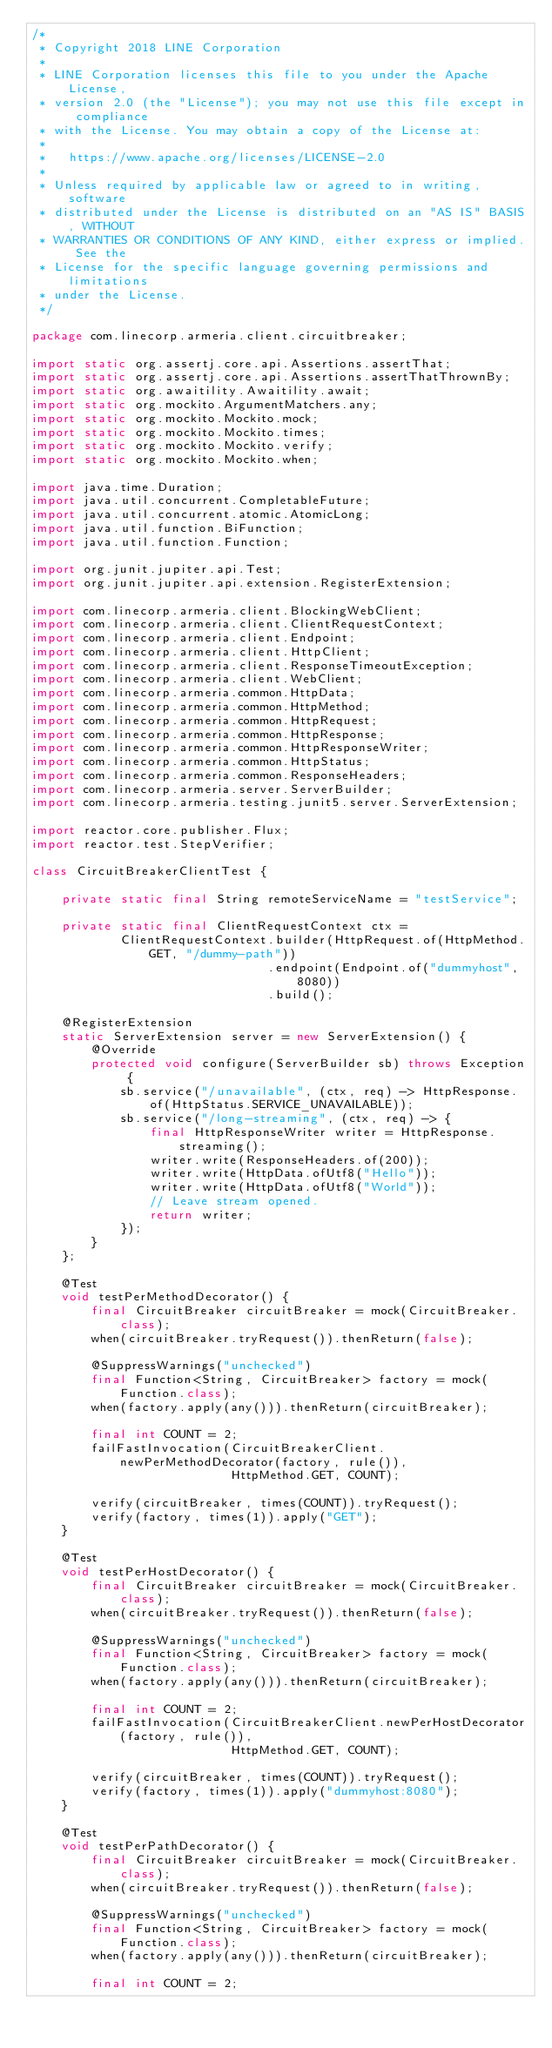<code> <loc_0><loc_0><loc_500><loc_500><_Java_>/*
 * Copyright 2018 LINE Corporation
 *
 * LINE Corporation licenses this file to you under the Apache License,
 * version 2.0 (the "License"); you may not use this file except in compliance
 * with the License. You may obtain a copy of the License at:
 *
 *   https://www.apache.org/licenses/LICENSE-2.0
 *
 * Unless required by applicable law or agreed to in writing, software
 * distributed under the License is distributed on an "AS IS" BASIS, WITHOUT
 * WARRANTIES OR CONDITIONS OF ANY KIND, either express or implied. See the
 * License for the specific language governing permissions and limitations
 * under the License.
 */

package com.linecorp.armeria.client.circuitbreaker;

import static org.assertj.core.api.Assertions.assertThat;
import static org.assertj.core.api.Assertions.assertThatThrownBy;
import static org.awaitility.Awaitility.await;
import static org.mockito.ArgumentMatchers.any;
import static org.mockito.Mockito.mock;
import static org.mockito.Mockito.times;
import static org.mockito.Mockito.verify;
import static org.mockito.Mockito.when;

import java.time.Duration;
import java.util.concurrent.CompletableFuture;
import java.util.concurrent.atomic.AtomicLong;
import java.util.function.BiFunction;
import java.util.function.Function;

import org.junit.jupiter.api.Test;
import org.junit.jupiter.api.extension.RegisterExtension;

import com.linecorp.armeria.client.BlockingWebClient;
import com.linecorp.armeria.client.ClientRequestContext;
import com.linecorp.armeria.client.Endpoint;
import com.linecorp.armeria.client.HttpClient;
import com.linecorp.armeria.client.ResponseTimeoutException;
import com.linecorp.armeria.client.WebClient;
import com.linecorp.armeria.common.HttpData;
import com.linecorp.armeria.common.HttpMethod;
import com.linecorp.armeria.common.HttpRequest;
import com.linecorp.armeria.common.HttpResponse;
import com.linecorp.armeria.common.HttpResponseWriter;
import com.linecorp.armeria.common.HttpStatus;
import com.linecorp.armeria.common.ResponseHeaders;
import com.linecorp.armeria.server.ServerBuilder;
import com.linecorp.armeria.testing.junit5.server.ServerExtension;

import reactor.core.publisher.Flux;
import reactor.test.StepVerifier;

class CircuitBreakerClientTest {

    private static final String remoteServiceName = "testService";

    private static final ClientRequestContext ctx =
            ClientRequestContext.builder(HttpRequest.of(HttpMethod.GET, "/dummy-path"))
                                .endpoint(Endpoint.of("dummyhost", 8080))
                                .build();

    @RegisterExtension
    static ServerExtension server = new ServerExtension() {
        @Override
        protected void configure(ServerBuilder sb) throws Exception {
            sb.service("/unavailable", (ctx, req) -> HttpResponse.of(HttpStatus.SERVICE_UNAVAILABLE));
            sb.service("/long-streaming", (ctx, req) -> {
                final HttpResponseWriter writer = HttpResponse.streaming();
                writer.write(ResponseHeaders.of(200));
                writer.write(HttpData.ofUtf8("Hello"));
                writer.write(HttpData.ofUtf8("World"));
                // Leave stream opened.
                return writer;
            });
        }
    };

    @Test
    void testPerMethodDecorator() {
        final CircuitBreaker circuitBreaker = mock(CircuitBreaker.class);
        when(circuitBreaker.tryRequest()).thenReturn(false);

        @SuppressWarnings("unchecked")
        final Function<String, CircuitBreaker> factory = mock(Function.class);
        when(factory.apply(any())).thenReturn(circuitBreaker);

        final int COUNT = 2;
        failFastInvocation(CircuitBreakerClient.newPerMethodDecorator(factory, rule()),
                           HttpMethod.GET, COUNT);

        verify(circuitBreaker, times(COUNT)).tryRequest();
        verify(factory, times(1)).apply("GET");
    }

    @Test
    void testPerHostDecorator() {
        final CircuitBreaker circuitBreaker = mock(CircuitBreaker.class);
        when(circuitBreaker.tryRequest()).thenReturn(false);

        @SuppressWarnings("unchecked")
        final Function<String, CircuitBreaker> factory = mock(Function.class);
        when(factory.apply(any())).thenReturn(circuitBreaker);

        final int COUNT = 2;
        failFastInvocation(CircuitBreakerClient.newPerHostDecorator(factory, rule()),
                           HttpMethod.GET, COUNT);

        verify(circuitBreaker, times(COUNT)).tryRequest();
        verify(factory, times(1)).apply("dummyhost:8080");
    }

    @Test
    void testPerPathDecorator() {
        final CircuitBreaker circuitBreaker = mock(CircuitBreaker.class);
        when(circuitBreaker.tryRequest()).thenReturn(false);

        @SuppressWarnings("unchecked")
        final Function<String, CircuitBreaker> factory = mock(Function.class);
        when(factory.apply(any())).thenReturn(circuitBreaker);

        final int COUNT = 2;</code> 